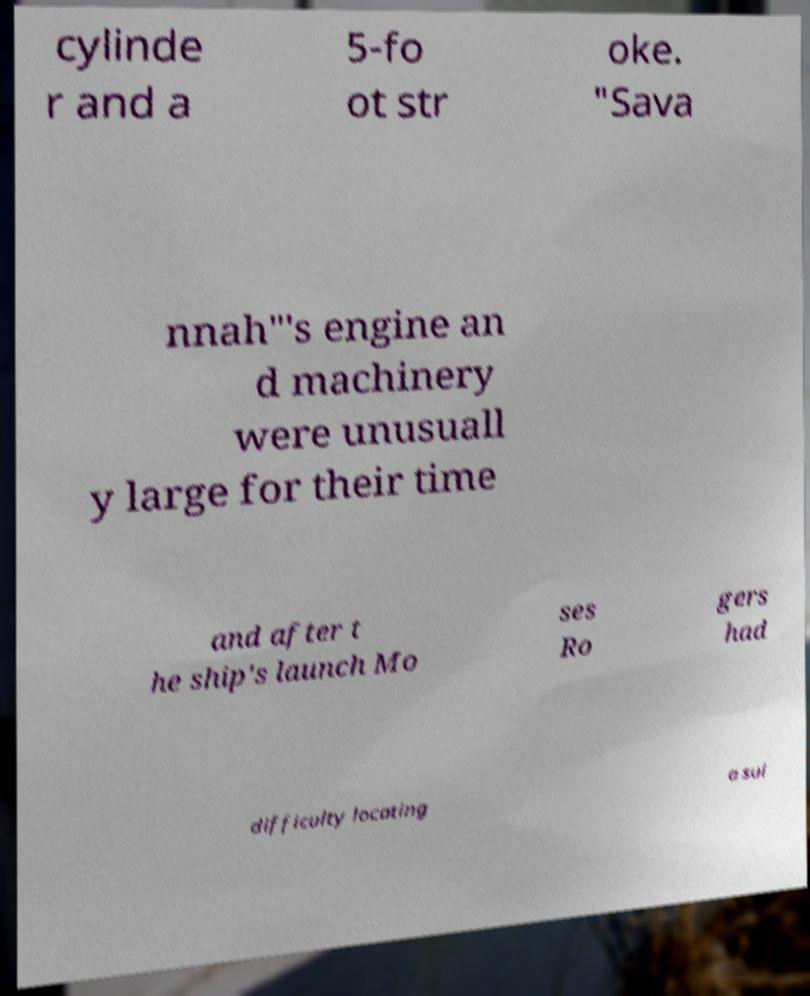There's text embedded in this image that I need extracted. Can you transcribe it verbatim? cylinde r and a 5-fo ot str oke. "Sava nnah"'s engine an d machinery were unusuall y large for their time and after t he ship's launch Mo ses Ro gers had difficulty locating a sui 